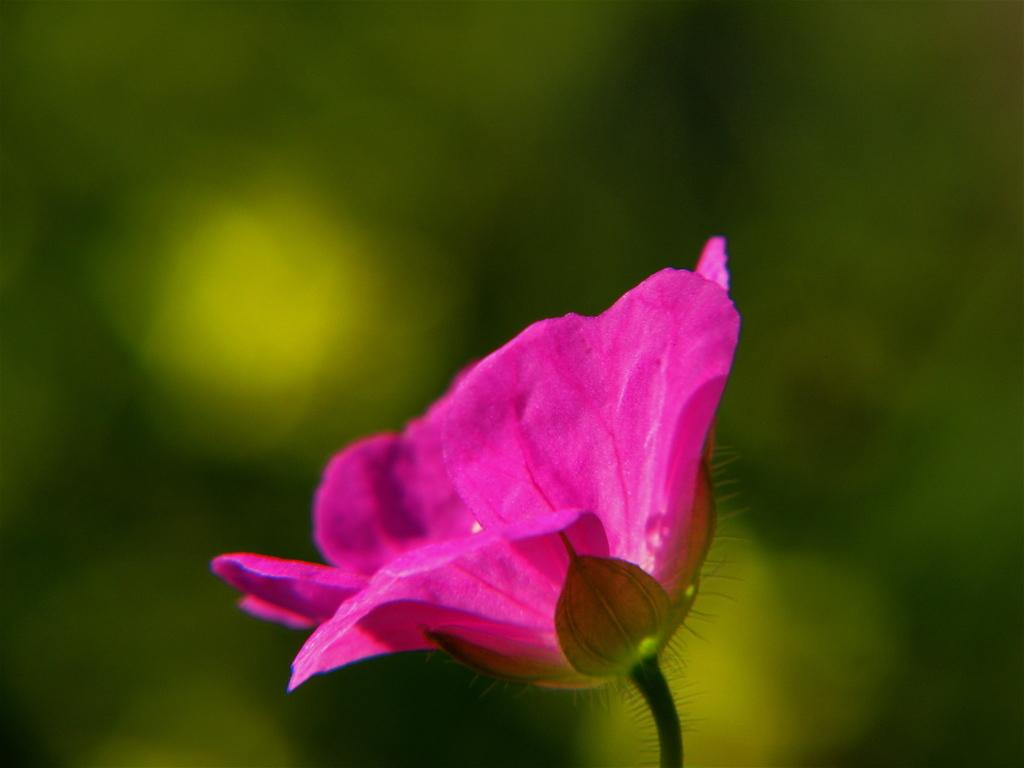What is the main subject of the image? There is a flower in the image. Can you describe the background of the image? The background of the image is blurred. What type of camp can be seen in the background of the image? There is no camp present in the image; it only features a flower and a blurred background. What role does the string play in the image? There is no string present in the image. 